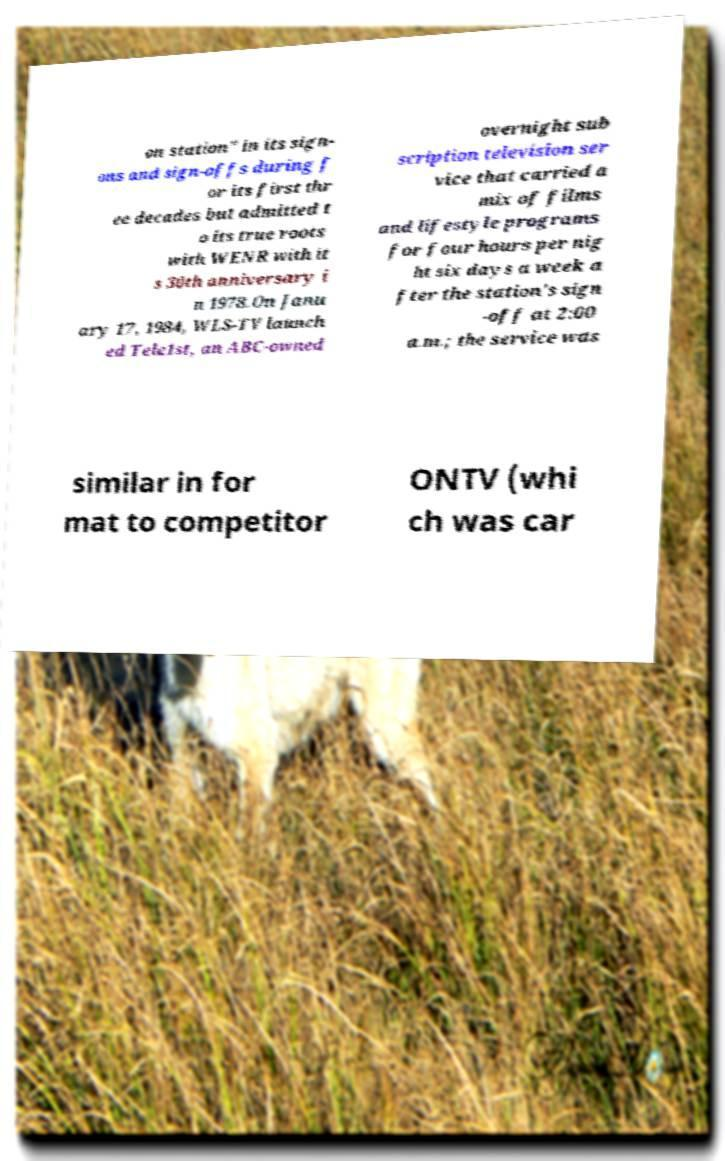What messages or text are displayed in this image? I need them in a readable, typed format. on station" in its sign- ons and sign-offs during f or its first thr ee decades but admitted t o its true roots with WENR with it s 30th anniversary i n 1978.On Janu ary 17, 1984, WLS-TV launch ed Tele1st, an ABC-owned overnight sub scription television ser vice that carried a mix of films and lifestyle programs for four hours per nig ht six days a week a fter the station's sign -off at 2:00 a.m.; the service was similar in for mat to competitor ONTV (whi ch was car 